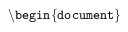Convert formula to latex. <formula><loc_0><loc_0><loc_500><loc_500>\ b e g i n \{ d o c u m e n t \}</formula> 